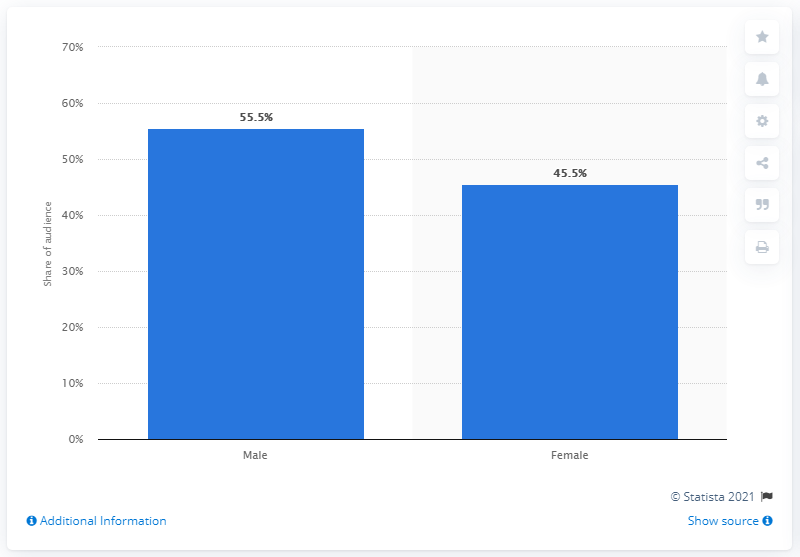Highlight a few significant elements in this photo. According to a survey of online audiences of financial services, 45.5% of the participants were women. 